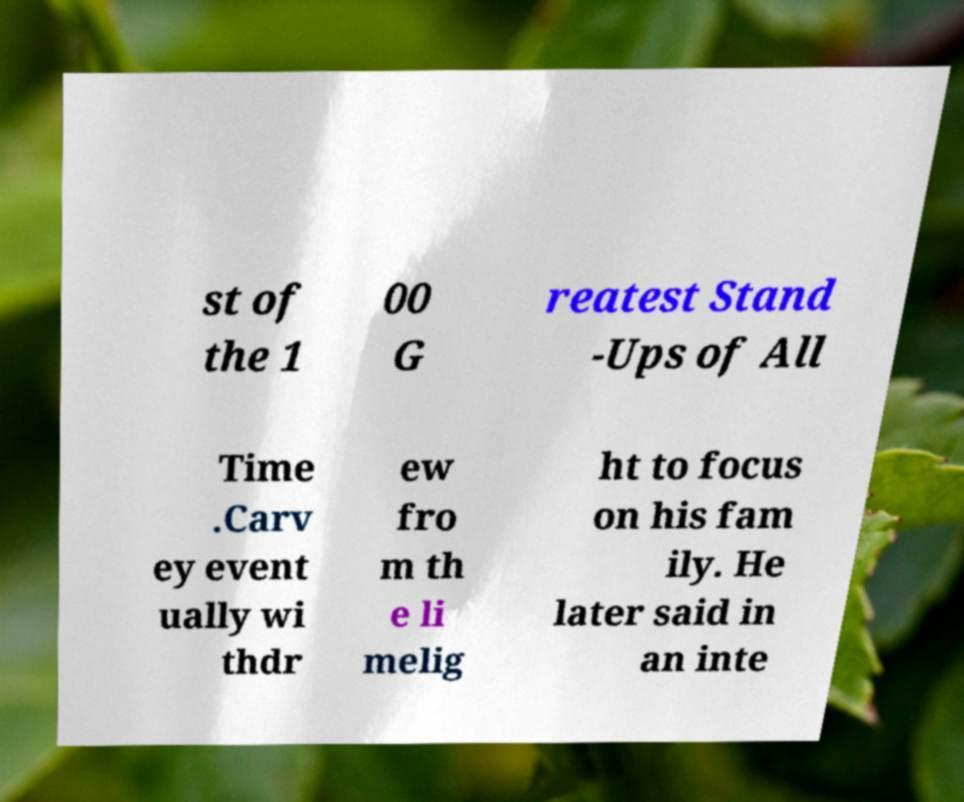Could you assist in decoding the text presented in this image and type it out clearly? st of the 1 00 G reatest Stand -Ups of All Time .Carv ey event ually wi thdr ew fro m th e li melig ht to focus on his fam ily. He later said in an inte 